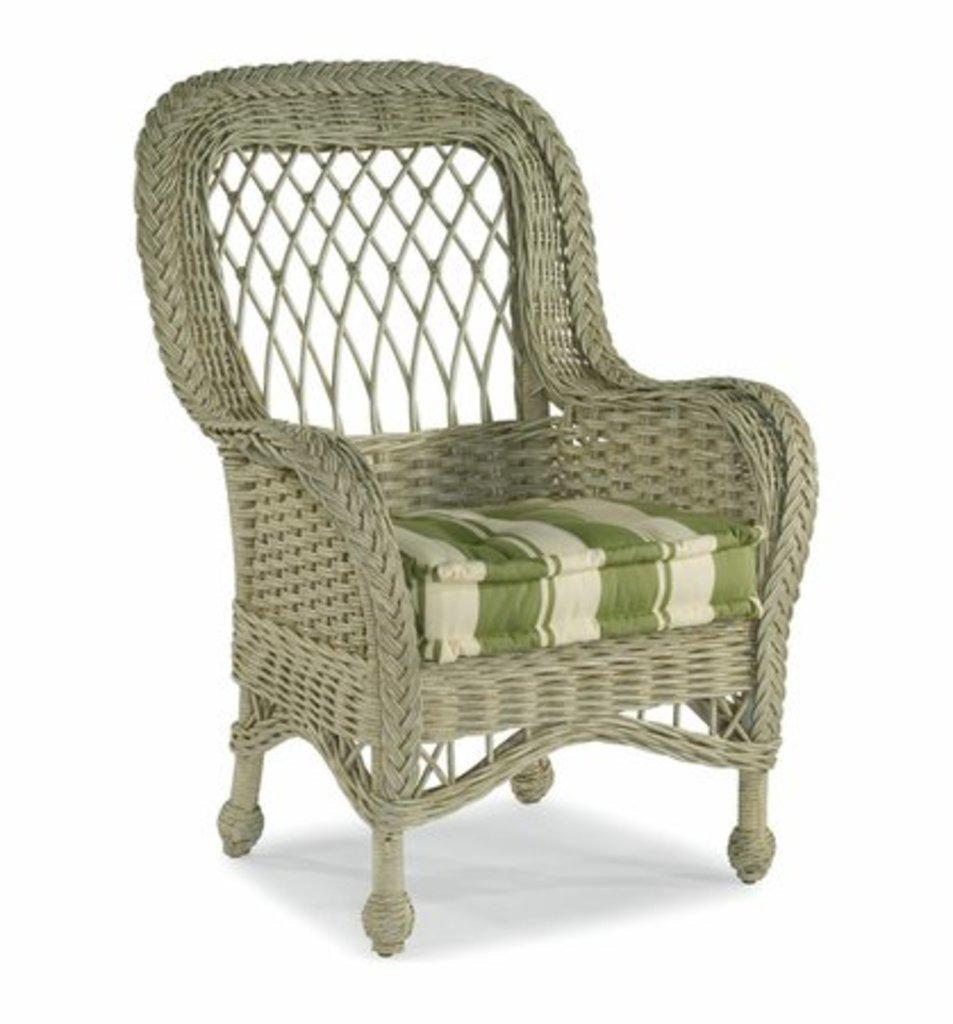What type of furniture is in the image? There is a chair in the image. What feature does the chair have? The chair has a cushion. What is the color or tone of the surface in the image? The image has a white surface. What type of calendar is hanging on the wall behind the chair in the image? There is no calendar present in the image; it only features a chair with a cushion on a white surface. 